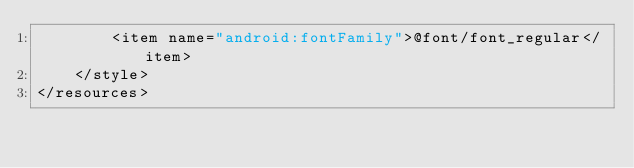Convert code to text. <code><loc_0><loc_0><loc_500><loc_500><_XML_>        <item name="android:fontFamily">@font/font_regular</item>
    </style>
</resources></code> 